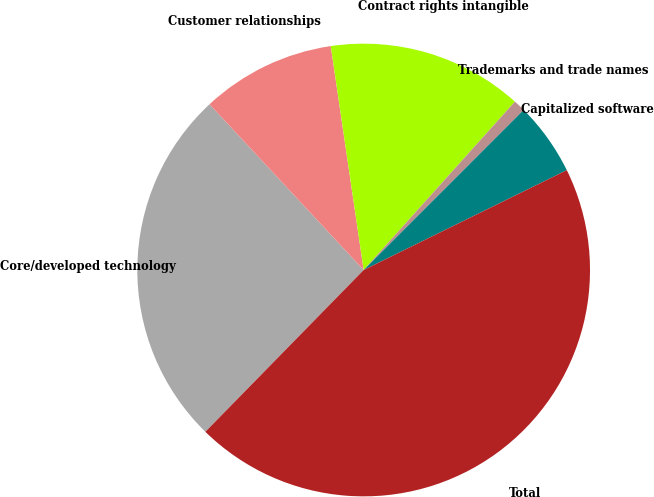Convert chart. <chart><loc_0><loc_0><loc_500><loc_500><pie_chart><fcel>Core/developed technology<fcel>Customer relationships<fcel>Contract rights intangible<fcel>Trademarks and trade names<fcel>Capitalized software<fcel>Total<nl><fcel>25.75%<fcel>9.6%<fcel>13.97%<fcel>0.85%<fcel>5.23%<fcel>44.6%<nl></chart> 